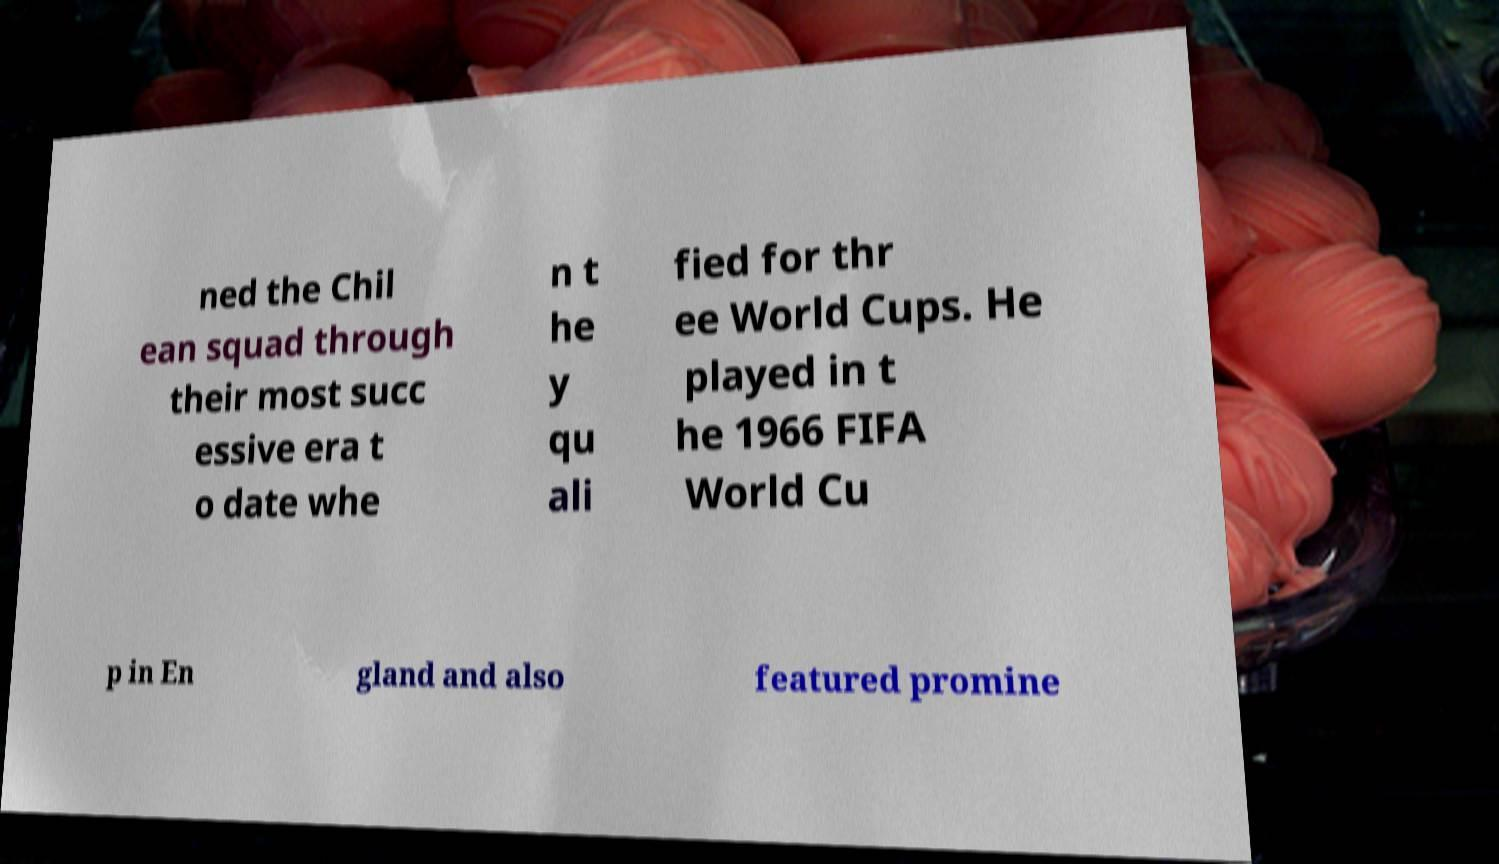Please identify and transcribe the text found in this image. ned the Chil ean squad through their most succ essive era t o date whe n t he y qu ali fied for thr ee World Cups. He played in t he 1966 FIFA World Cu p in En gland and also featured promine 